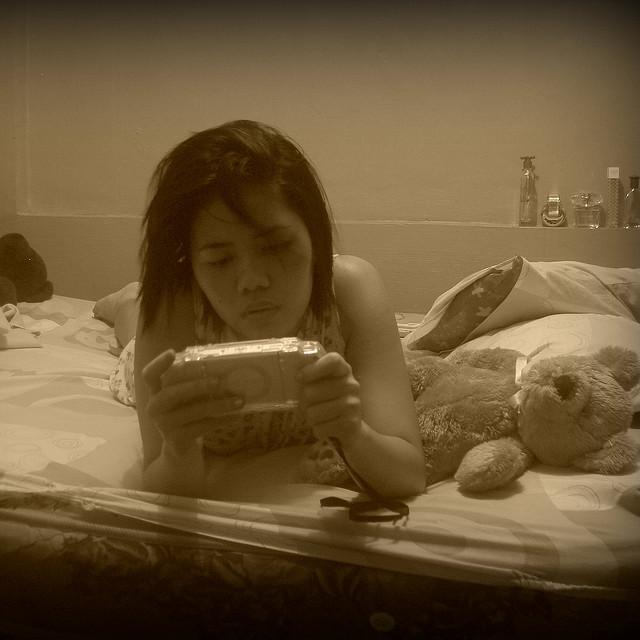How many people are in the photo?
Give a very brief answer. 1. 